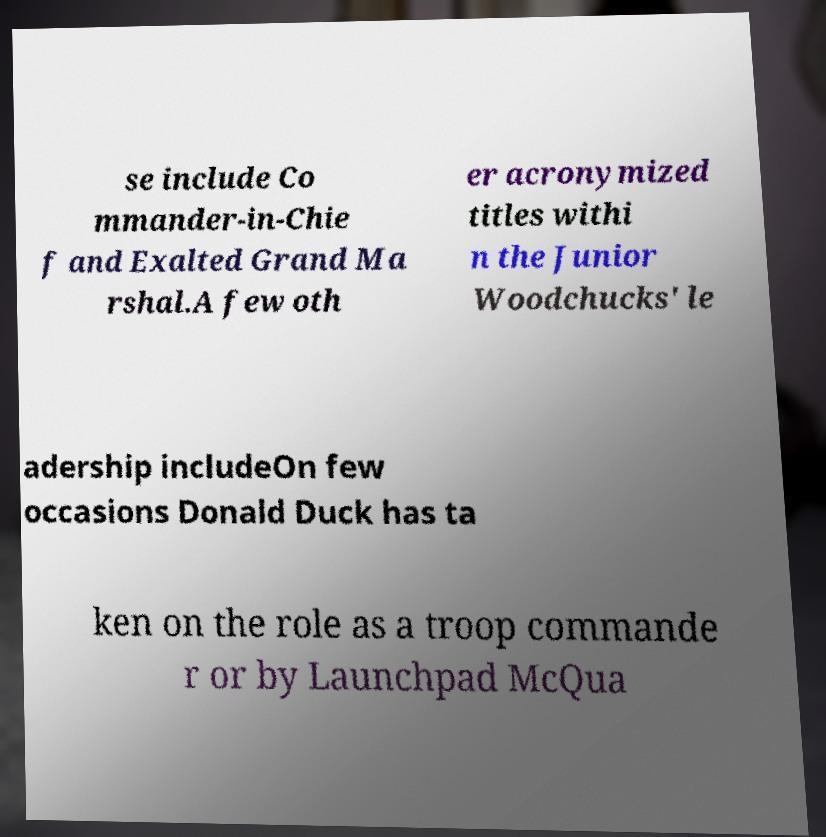Please identify and transcribe the text found in this image. se include Co mmander-in-Chie f and Exalted Grand Ma rshal.A few oth er acronymized titles withi n the Junior Woodchucks' le adership includeOn few occasions Donald Duck has ta ken on the role as a troop commande r or by Launchpad McQua 